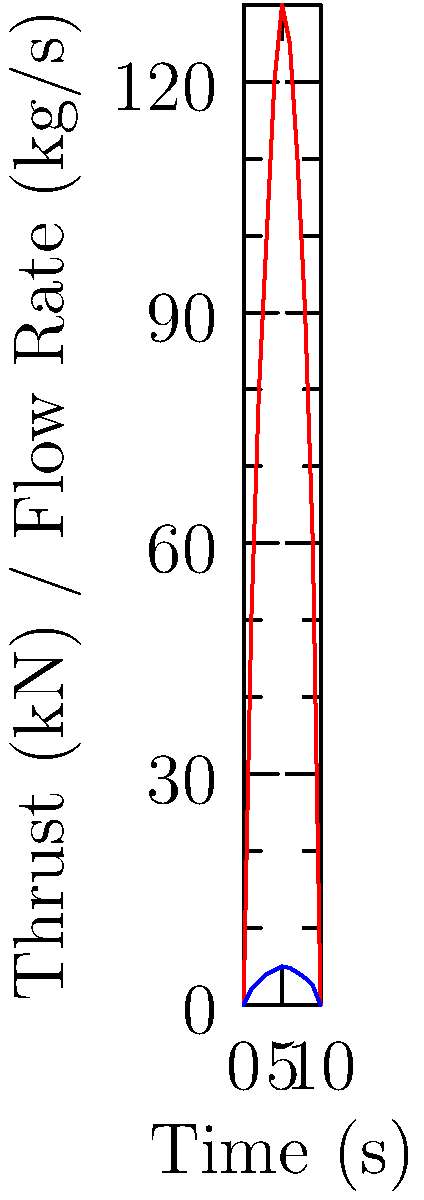Given the thrust and propellant flow rate graphs for a pre-space age rocket engine test, calculate the average specific impulse ($I_{sp}$) over the 10-second burn duration. Assume standard gravity ($g_0$) is 9.81 m/s². Express your answer in seconds, rounded to the nearest whole number. To calculate the average specific impulse ($I_{sp}$), we'll follow these steps:

1) The specific impulse is given by the formula:

   $$I_{sp} = \frac{F}{{\dot{m} \cdot g_0}}$$

   where $F$ is thrust, $\dot{m}$ is mass flow rate, and $g_0$ is standard gravity.

2) We need to calculate the average thrust and average flow rate over the 10-second period:

   Average Thrust:
   $$(50 + 80 + 100 + 120 + 130 + 125 + 110 + 90 + 60) \div 9 = 96.11 \text{ kN}$$

   Average Flow Rate:
   $$(2 + 3 + 4 + 4.5 + 5 + 4.8 + 4.2 + 3.5 + 2.5) \div 9 = 3.72 \text{ kg/s}$$

3) Now we can substitute these values into our equation:

   $$I_{sp} = \frac{96110 \text{ N}}{3.72 \text{ kg/s} \cdot 9.81 \text{ m/s²}}$$

4) Simplifying:

   $$I_{sp} = \frac{96110}{36.4932} = 2633.64 \text{ s}$$

5) Rounding to the nearest whole number:

   $$I_{sp} \approx 2634 \text{ s}$$
Answer: 2634 s 